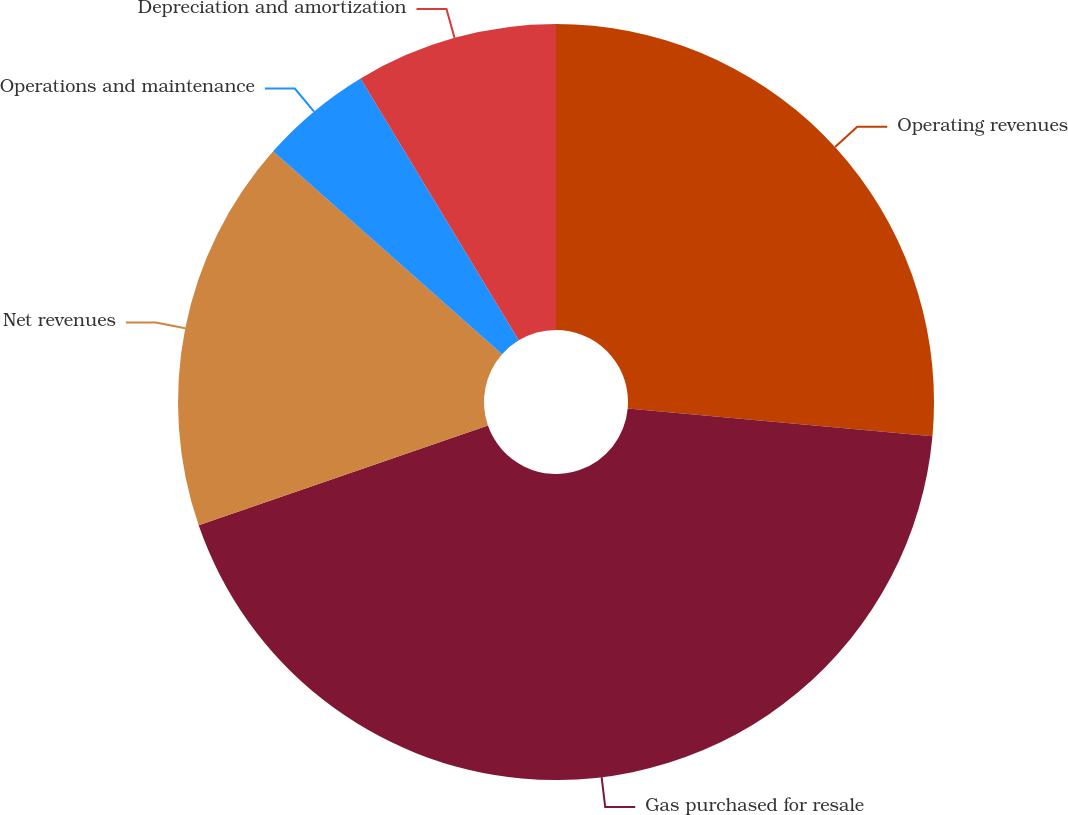<chart> <loc_0><loc_0><loc_500><loc_500><pie_chart><fcel>Operating revenues<fcel>Gas purchased for resale<fcel>Net revenues<fcel>Operations and maintenance<fcel>Depreciation and amortization<nl><fcel>26.44%<fcel>43.27%<fcel>16.83%<fcel>4.81%<fcel>8.65%<nl></chart> 